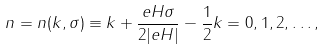<formula> <loc_0><loc_0><loc_500><loc_500>n = n ( k , \sigma ) \equiv k + \frac { e H \sigma } { 2 | e H | } - \frac { 1 } { 2 } k = 0 , 1 , 2 , \dots ,</formula> 